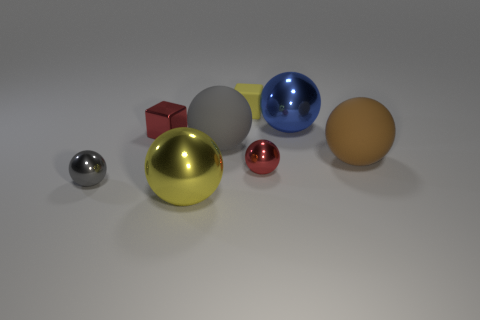There is another large thing that is the same material as the big gray thing; what shape is it?
Offer a terse response. Sphere. There is a object that is both behind the big gray thing and to the left of the rubber block; what material is it?
Provide a short and direct response. Metal. The big metallic thing that is the same color as the small rubber object is what shape?
Offer a terse response. Sphere. What number of yellow matte things have the same shape as the brown rubber object?
Offer a terse response. 0. There is a yellow object that is made of the same material as the brown ball; what size is it?
Your response must be concise. Small. Do the yellow shiny object and the matte block have the same size?
Offer a very short reply. No. Is there a large yellow rubber thing?
Ensure brevity in your answer.  No. What size is the other thing that is the same color as the tiny matte thing?
Provide a succinct answer. Large. There is a yellow object behind the metal ball in front of the small shiny object in front of the red shiny ball; what is its size?
Provide a succinct answer. Small. How many big brown objects are the same material as the yellow sphere?
Offer a very short reply. 0. 